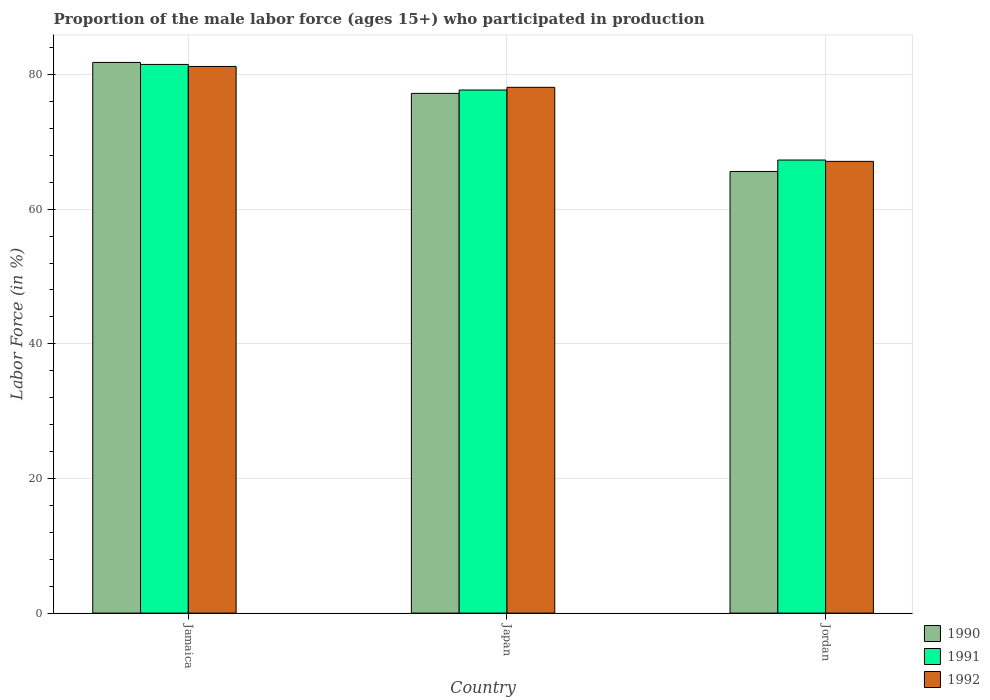How many different coloured bars are there?
Make the answer very short. 3. How many groups of bars are there?
Keep it short and to the point. 3. Are the number of bars per tick equal to the number of legend labels?
Offer a very short reply. Yes. Are the number of bars on each tick of the X-axis equal?
Ensure brevity in your answer.  Yes. What is the label of the 3rd group of bars from the left?
Provide a short and direct response. Jordan. What is the proportion of the male labor force who participated in production in 1990 in Jamaica?
Your response must be concise. 81.8. Across all countries, what is the maximum proportion of the male labor force who participated in production in 1991?
Your answer should be compact. 81.5. Across all countries, what is the minimum proportion of the male labor force who participated in production in 1990?
Your answer should be very brief. 65.6. In which country was the proportion of the male labor force who participated in production in 1992 maximum?
Give a very brief answer. Jamaica. In which country was the proportion of the male labor force who participated in production in 1990 minimum?
Offer a very short reply. Jordan. What is the total proportion of the male labor force who participated in production in 1990 in the graph?
Your answer should be compact. 224.6. What is the difference between the proportion of the male labor force who participated in production in 1990 in Jamaica and that in Japan?
Make the answer very short. 4.6. What is the difference between the proportion of the male labor force who participated in production in 1990 in Japan and the proportion of the male labor force who participated in production in 1991 in Jordan?
Your answer should be compact. 9.9. What is the average proportion of the male labor force who participated in production in 1990 per country?
Provide a succinct answer. 74.87. What is the difference between the proportion of the male labor force who participated in production of/in 1991 and proportion of the male labor force who participated in production of/in 1992 in Japan?
Offer a terse response. -0.4. What is the ratio of the proportion of the male labor force who participated in production in 1991 in Japan to that in Jordan?
Offer a terse response. 1.15. Is the proportion of the male labor force who participated in production in 1991 in Jamaica less than that in Japan?
Provide a succinct answer. No. What is the difference between the highest and the second highest proportion of the male labor force who participated in production in 1991?
Give a very brief answer. 14.2. What is the difference between the highest and the lowest proportion of the male labor force who participated in production in 1991?
Give a very brief answer. 14.2. In how many countries, is the proportion of the male labor force who participated in production in 1990 greater than the average proportion of the male labor force who participated in production in 1990 taken over all countries?
Keep it short and to the point. 2. What does the 3rd bar from the left in Jamaica represents?
Offer a very short reply. 1992. Is it the case that in every country, the sum of the proportion of the male labor force who participated in production in 1990 and proportion of the male labor force who participated in production in 1991 is greater than the proportion of the male labor force who participated in production in 1992?
Give a very brief answer. Yes. How many bars are there?
Offer a terse response. 9. Are all the bars in the graph horizontal?
Your answer should be compact. No. Does the graph contain grids?
Make the answer very short. Yes. How many legend labels are there?
Ensure brevity in your answer.  3. What is the title of the graph?
Your response must be concise. Proportion of the male labor force (ages 15+) who participated in production. Does "1962" appear as one of the legend labels in the graph?
Offer a very short reply. No. What is the label or title of the X-axis?
Offer a terse response. Country. What is the Labor Force (in %) of 1990 in Jamaica?
Your answer should be compact. 81.8. What is the Labor Force (in %) in 1991 in Jamaica?
Your response must be concise. 81.5. What is the Labor Force (in %) of 1992 in Jamaica?
Offer a very short reply. 81.2. What is the Labor Force (in %) in 1990 in Japan?
Provide a succinct answer. 77.2. What is the Labor Force (in %) in 1991 in Japan?
Provide a short and direct response. 77.7. What is the Labor Force (in %) in 1992 in Japan?
Provide a succinct answer. 78.1. What is the Labor Force (in %) of 1990 in Jordan?
Provide a succinct answer. 65.6. What is the Labor Force (in %) of 1991 in Jordan?
Ensure brevity in your answer.  67.3. What is the Labor Force (in %) in 1992 in Jordan?
Offer a terse response. 67.1. Across all countries, what is the maximum Labor Force (in %) of 1990?
Make the answer very short. 81.8. Across all countries, what is the maximum Labor Force (in %) of 1991?
Your answer should be compact. 81.5. Across all countries, what is the maximum Labor Force (in %) of 1992?
Provide a short and direct response. 81.2. Across all countries, what is the minimum Labor Force (in %) in 1990?
Ensure brevity in your answer.  65.6. Across all countries, what is the minimum Labor Force (in %) in 1991?
Your response must be concise. 67.3. Across all countries, what is the minimum Labor Force (in %) in 1992?
Offer a very short reply. 67.1. What is the total Labor Force (in %) of 1990 in the graph?
Make the answer very short. 224.6. What is the total Labor Force (in %) of 1991 in the graph?
Offer a terse response. 226.5. What is the total Labor Force (in %) of 1992 in the graph?
Provide a short and direct response. 226.4. What is the difference between the Labor Force (in %) in 1990 in Jamaica and that in Japan?
Provide a short and direct response. 4.6. What is the difference between the Labor Force (in %) in 1991 in Jamaica and that in Japan?
Make the answer very short. 3.8. What is the difference between the Labor Force (in %) in 1992 in Jamaica and that in Japan?
Your response must be concise. 3.1. What is the difference between the Labor Force (in %) in 1991 in Jamaica and that in Jordan?
Ensure brevity in your answer.  14.2. What is the difference between the Labor Force (in %) of 1990 in Japan and that in Jordan?
Offer a terse response. 11.6. What is the difference between the Labor Force (in %) of 1992 in Japan and that in Jordan?
Offer a very short reply. 11. What is the difference between the Labor Force (in %) of 1990 in Jamaica and the Labor Force (in %) of 1992 in Japan?
Your answer should be compact. 3.7. What is the difference between the Labor Force (in %) of 1991 in Jamaica and the Labor Force (in %) of 1992 in Japan?
Make the answer very short. 3.4. What is the difference between the Labor Force (in %) in 1990 in Jamaica and the Labor Force (in %) in 1991 in Jordan?
Your answer should be very brief. 14.5. What is the difference between the Labor Force (in %) in 1990 in Jamaica and the Labor Force (in %) in 1992 in Jordan?
Keep it short and to the point. 14.7. What is the difference between the Labor Force (in %) in 1990 in Japan and the Labor Force (in %) in 1991 in Jordan?
Keep it short and to the point. 9.9. What is the difference between the Labor Force (in %) in 1990 in Japan and the Labor Force (in %) in 1992 in Jordan?
Keep it short and to the point. 10.1. What is the average Labor Force (in %) of 1990 per country?
Offer a terse response. 74.87. What is the average Labor Force (in %) of 1991 per country?
Keep it short and to the point. 75.5. What is the average Labor Force (in %) of 1992 per country?
Your answer should be compact. 75.47. What is the difference between the Labor Force (in %) of 1990 and Labor Force (in %) of 1992 in Jamaica?
Offer a very short reply. 0.6. What is the difference between the Labor Force (in %) of 1990 and Labor Force (in %) of 1992 in Japan?
Make the answer very short. -0.9. What is the difference between the Labor Force (in %) in 1991 and Labor Force (in %) in 1992 in Japan?
Keep it short and to the point. -0.4. What is the difference between the Labor Force (in %) of 1990 and Labor Force (in %) of 1992 in Jordan?
Provide a short and direct response. -1.5. What is the ratio of the Labor Force (in %) in 1990 in Jamaica to that in Japan?
Offer a terse response. 1.06. What is the ratio of the Labor Force (in %) in 1991 in Jamaica to that in Japan?
Ensure brevity in your answer.  1.05. What is the ratio of the Labor Force (in %) in 1992 in Jamaica to that in Japan?
Your response must be concise. 1.04. What is the ratio of the Labor Force (in %) of 1990 in Jamaica to that in Jordan?
Your answer should be compact. 1.25. What is the ratio of the Labor Force (in %) in 1991 in Jamaica to that in Jordan?
Provide a short and direct response. 1.21. What is the ratio of the Labor Force (in %) in 1992 in Jamaica to that in Jordan?
Your answer should be very brief. 1.21. What is the ratio of the Labor Force (in %) of 1990 in Japan to that in Jordan?
Offer a very short reply. 1.18. What is the ratio of the Labor Force (in %) in 1991 in Japan to that in Jordan?
Provide a succinct answer. 1.15. What is the ratio of the Labor Force (in %) of 1992 in Japan to that in Jordan?
Offer a terse response. 1.16. What is the difference between the highest and the second highest Labor Force (in %) of 1991?
Your answer should be compact. 3.8. What is the difference between the highest and the lowest Labor Force (in %) in 1991?
Make the answer very short. 14.2. What is the difference between the highest and the lowest Labor Force (in %) of 1992?
Provide a succinct answer. 14.1. 